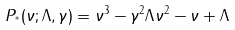Convert formula to latex. <formula><loc_0><loc_0><loc_500><loc_500>P _ { ^ { * } } ( \nu ; \Lambda , \gamma ) = \nu ^ { 3 } - \gamma ^ { 2 } \Lambda \nu ^ { 2 } - \nu + \Lambda</formula> 